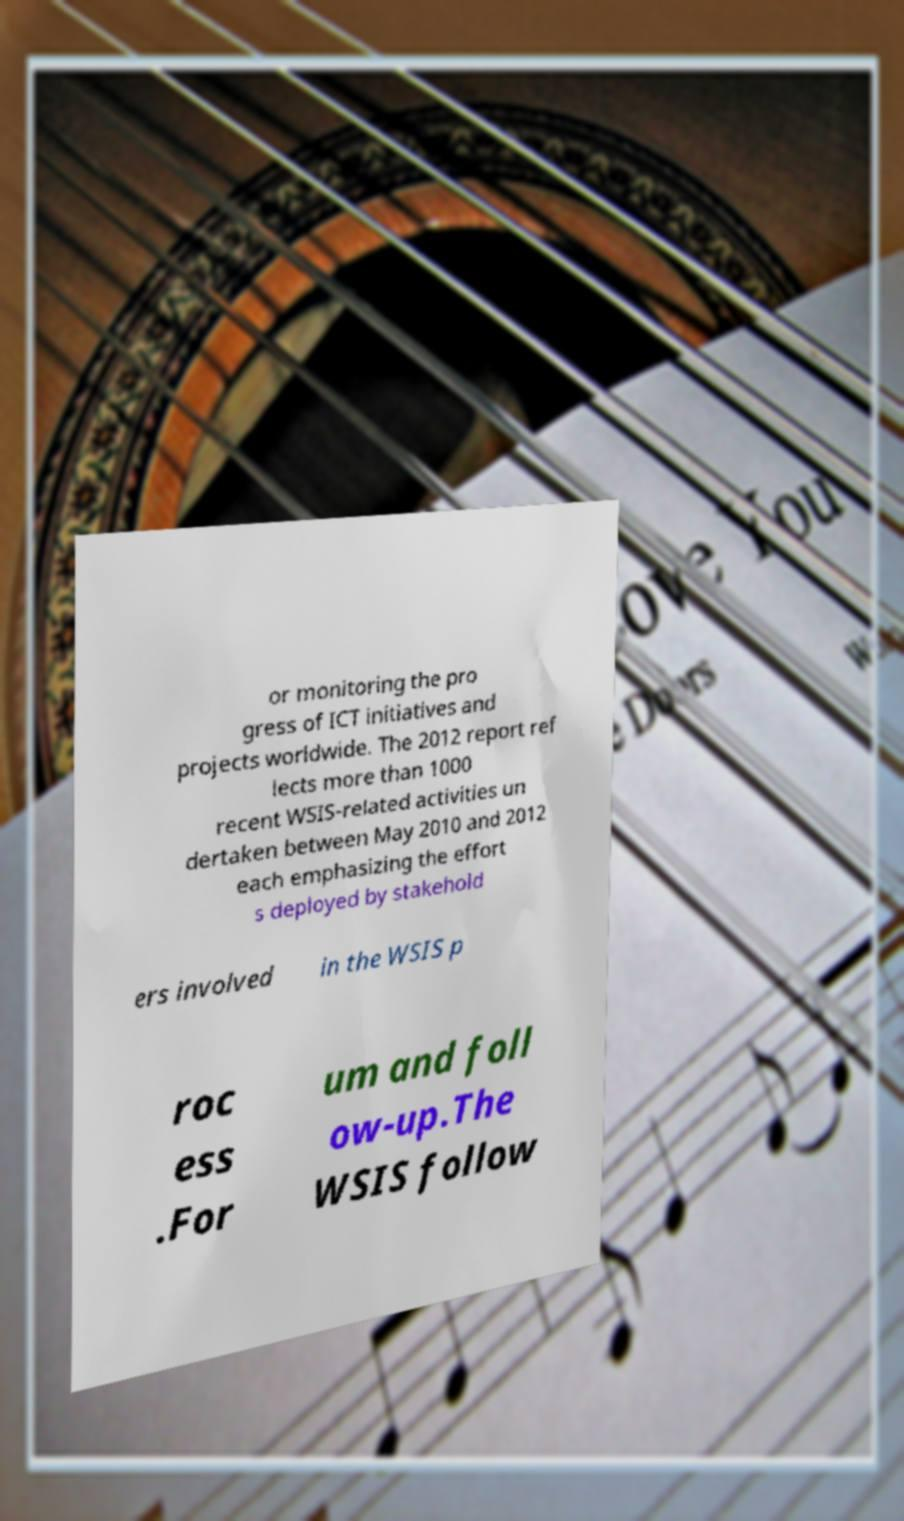Could you extract and type out the text from this image? or monitoring the pro gress of ICT initiatives and projects worldwide. The 2012 report ref lects more than 1000 recent WSIS-related activities un dertaken between May 2010 and 2012 each emphasizing the effort s deployed by stakehold ers involved in the WSIS p roc ess .For um and foll ow-up.The WSIS follow 